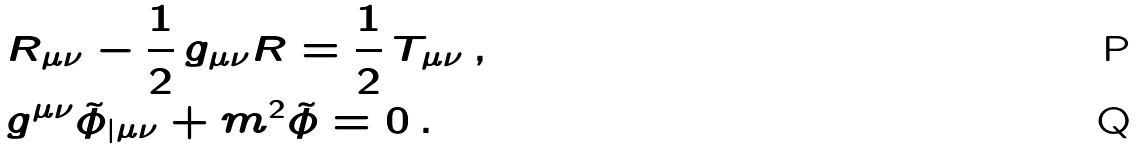Convert formula to latex. <formula><loc_0><loc_0><loc_500><loc_500>& R _ { \mu \nu } - \frac { 1 } { 2 } \, g _ { \mu \nu } R = \frac { 1 } { 2 } \, T _ { \mu \nu } \, , \\ & g ^ { \mu \nu } \tilde { \phi } _ { | \mu \nu } + m ^ { 2 } \tilde { \phi } = 0 \, .</formula> 